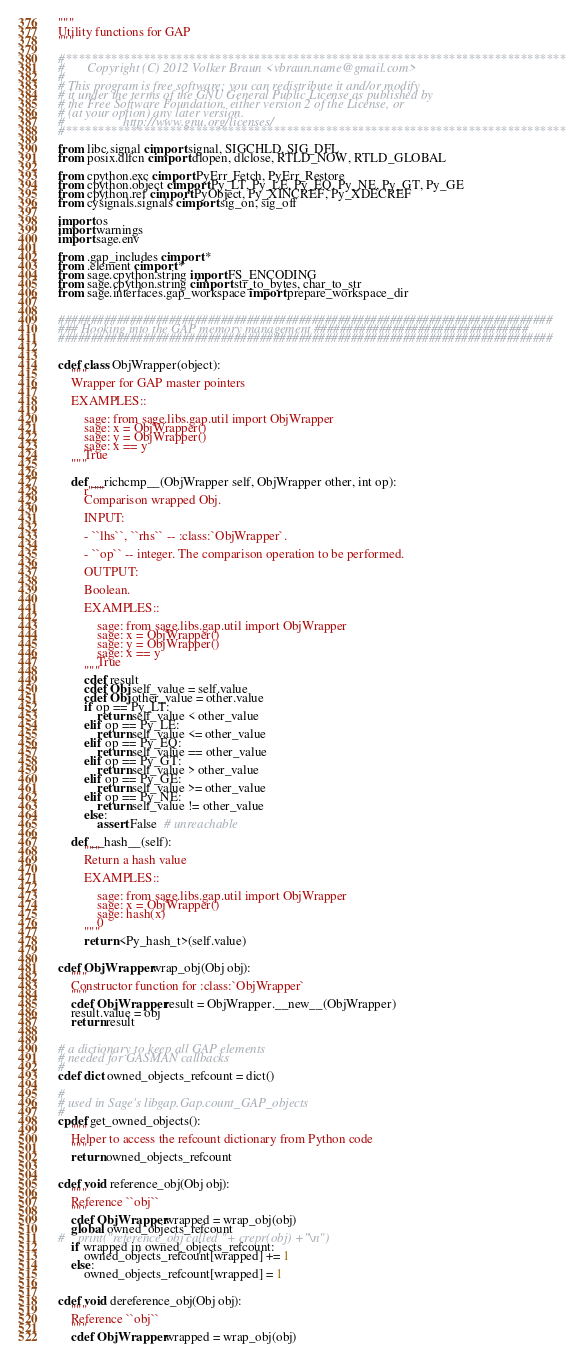<code> <loc_0><loc_0><loc_500><loc_500><_Cython_>"""
Utility functions for GAP
"""

#*****************************************************************************
#       Copyright (C) 2012 Volker Braun <vbraun.name@gmail.com>
#
# This program is free software: you can redistribute it and/or modify
# it under the terms of the GNU General Public License as published by
# the Free Software Foundation, either version 2 of the License, or
# (at your option) any later version.
#                  http://www.gnu.org/licenses/
#*****************************************************************************

from libc.signal cimport signal, SIGCHLD, SIG_DFL
from posix.dlfcn cimport dlopen, dlclose, RTLD_NOW, RTLD_GLOBAL

from cpython.exc cimport PyErr_Fetch, PyErr_Restore
from cpython.object cimport Py_LT, Py_LE, Py_EQ, Py_NE, Py_GT, Py_GE
from cpython.ref cimport PyObject, Py_XINCREF, Py_XDECREF
from cysignals.signals cimport sig_on, sig_off

import os
import warnings
import sage.env

from .gap_includes cimport *
from .element cimport *
from sage.cpython.string import FS_ENCODING
from sage.cpython.string cimport str_to_bytes, char_to_str
from sage.interfaces.gap_workspace import prepare_workspace_dir


############################################################################
### Hooking into the GAP memory management #################################
############################################################################


cdef class ObjWrapper(object):
    """
    Wrapper for GAP master pointers

    EXAMPLES::

        sage: from sage.libs.gap.util import ObjWrapper
        sage: x = ObjWrapper()
        sage: y = ObjWrapper()
        sage: x == y
        True
    """

    def __richcmp__(ObjWrapper self, ObjWrapper other, int op):
        r"""
        Comparison wrapped Obj.

        INPUT:

        - ``lhs``, ``rhs`` -- :class:`ObjWrapper`.

        - ``op`` -- integer. The comparison operation to be performed.

        OUTPUT:

        Boolean.

        EXAMPLES::

            sage: from sage.libs.gap.util import ObjWrapper
            sage: x = ObjWrapper()
            sage: y = ObjWrapper()
            sage: x == y
            True
        """
        cdef result
        cdef Obj self_value = self.value
        cdef Obj other_value = other.value
        if op == Py_LT:
            return self_value < other_value
        elif op == Py_LE:
            return self_value <= other_value
        elif op == Py_EQ:
            return self_value == other_value
        elif op == Py_GT:
            return self_value > other_value
        elif op == Py_GE:
            return self_value >= other_value
        elif op == Py_NE:
            return self_value != other_value
        else:
            assert False  # unreachable

    def __hash__(self):
        """
        Return a hash value

        EXAMPLES::

            sage: from sage.libs.gap.util import ObjWrapper
            sage: x = ObjWrapper()
            sage: hash(x)
            0
        """
        return <Py_hash_t>(self.value)


cdef ObjWrapper wrap_obj(Obj obj):
    """
    Constructor function for :class:`ObjWrapper`
    """
    cdef ObjWrapper result = ObjWrapper.__new__(ObjWrapper)
    result.value = obj
    return result


# a dictionary to keep all GAP elements
# needed for GASMAN callbacks
#
cdef dict owned_objects_refcount = dict()

#
# used in Sage's libgap.Gap.count_GAP_objects
#
cpdef get_owned_objects():
    """
    Helper to access the refcount dictionary from Python code
    """
    return owned_objects_refcount


cdef void reference_obj(Obj obj):
    """
    Reference ``obj``
    """
    cdef ObjWrapper wrapped = wrap_obj(obj)
    global owned_objects_refcount
#    print("reference_obj called "+ crepr(obj) +"\n")
    if wrapped in owned_objects_refcount:
        owned_objects_refcount[wrapped] += 1
    else:
        owned_objects_refcount[wrapped] = 1


cdef void dereference_obj(Obj obj):
    """
    Reference ``obj``
    """
    cdef ObjWrapper wrapped = wrap_obj(obj)</code> 